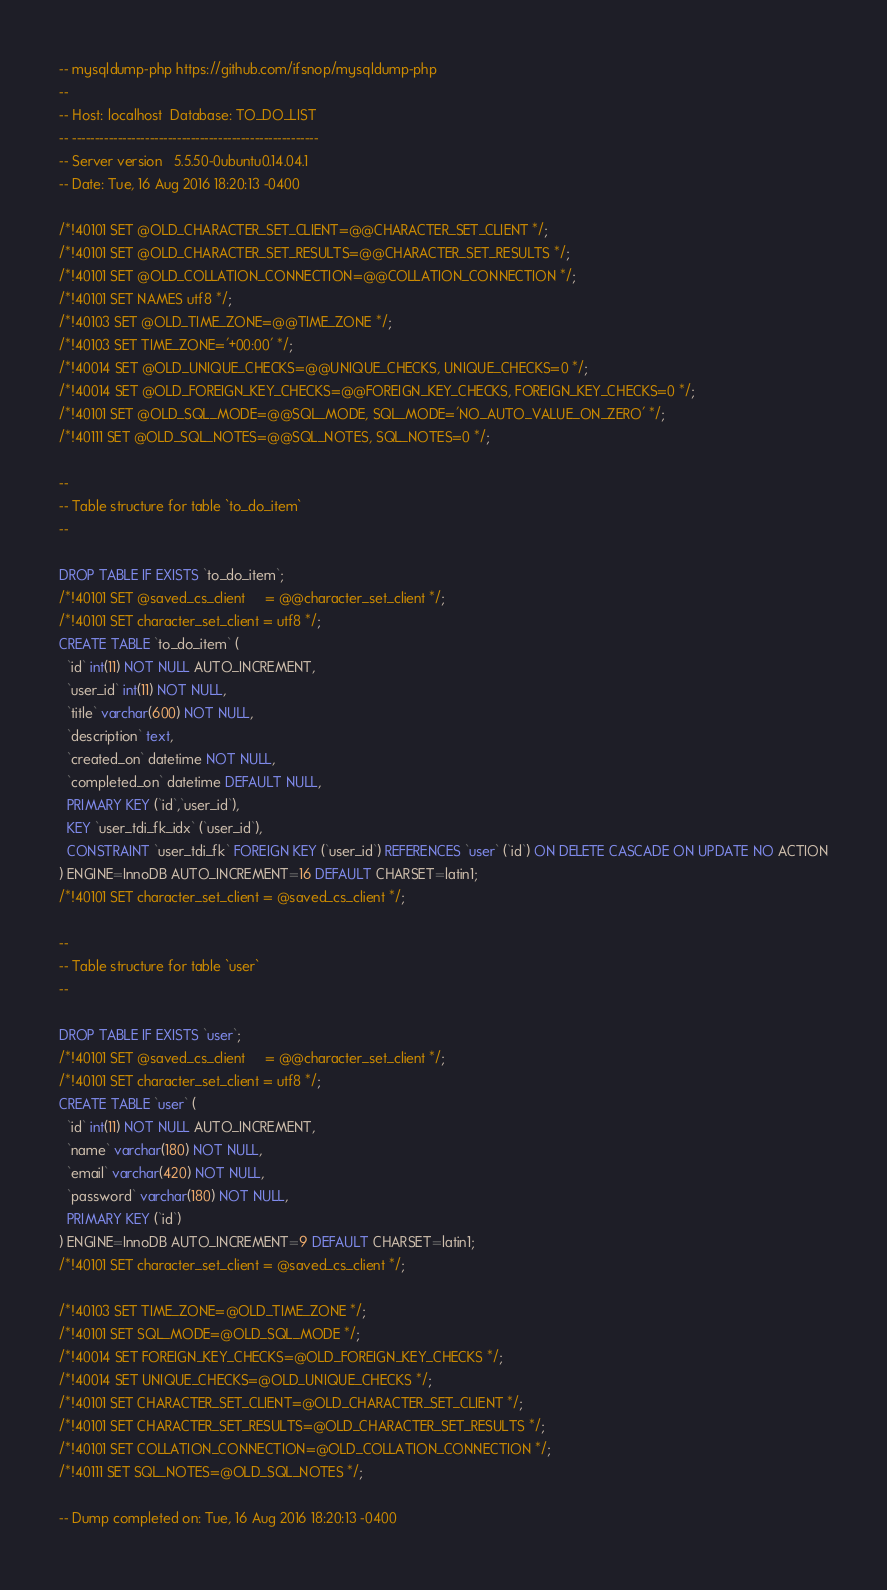Convert code to text. <code><loc_0><loc_0><loc_500><loc_500><_SQL_>-- mysqldump-php https://github.com/ifsnop/mysqldump-php
--
-- Host: localhost	Database: TO_DO_LIST
-- ------------------------------------------------------
-- Server version 	5.5.50-0ubuntu0.14.04.1
-- Date: Tue, 16 Aug 2016 18:20:13 -0400

/*!40101 SET @OLD_CHARACTER_SET_CLIENT=@@CHARACTER_SET_CLIENT */;
/*!40101 SET @OLD_CHARACTER_SET_RESULTS=@@CHARACTER_SET_RESULTS */;
/*!40101 SET @OLD_COLLATION_CONNECTION=@@COLLATION_CONNECTION */;
/*!40101 SET NAMES utf8 */;
/*!40103 SET @OLD_TIME_ZONE=@@TIME_ZONE */;
/*!40103 SET TIME_ZONE='+00:00' */;
/*!40014 SET @OLD_UNIQUE_CHECKS=@@UNIQUE_CHECKS, UNIQUE_CHECKS=0 */;
/*!40014 SET @OLD_FOREIGN_KEY_CHECKS=@@FOREIGN_KEY_CHECKS, FOREIGN_KEY_CHECKS=0 */;
/*!40101 SET @OLD_SQL_MODE=@@SQL_MODE, SQL_MODE='NO_AUTO_VALUE_ON_ZERO' */;
/*!40111 SET @OLD_SQL_NOTES=@@SQL_NOTES, SQL_NOTES=0 */;

--
-- Table structure for table `to_do_item`
--

DROP TABLE IF EXISTS `to_do_item`;
/*!40101 SET @saved_cs_client     = @@character_set_client */;
/*!40101 SET character_set_client = utf8 */;
CREATE TABLE `to_do_item` (
  `id` int(11) NOT NULL AUTO_INCREMENT,
  `user_id` int(11) NOT NULL,
  `title` varchar(600) NOT NULL,
  `description` text,
  `created_on` datetime NOT NULL,
  `completed_on` datetime DEFAULT NULL,
  PRIMARY KEY (`id`,`user_id`),
  KEY `user_tdi_fk_idx` (`user_id`),
  CONSTRAINT `user_tdi_fk` FOREIGN KEY (`user_id`) REFERENCES `user` (`id`) ON DELETE CASCADE ON UPDATE NO ACTION
) ENGINE=InnoDB AUTO_INCREMENT=16 DEFAULT CHARSET=latin1;
/*!40101 SET character_set_client = @saved_cs_client */;

--
-- Table structure for table `user`
--

DROP TABLE IF EXISTS `user`;
/*!40101 SET @saved_cs_client     = @@character_set_client */;
/*!40101 SET character_set_client = utf8 */;
CREATE TABLE `user` (
  `id` int(11) NOT NULL AUTO_INCREMENT,
  `name` varchar(180) NOT NULL,
  `email` varchar(420) NOT NULL,
  `password` varchar(180) NOT NULL,
  PRIMARY KEY (`id`)
) ENGINE=InnoDB AUTO_INCREMENT=9 DEFAULT CHARSET=latin1;
/*!40101 SET character_set_client = @saved_cs_client */;

/*!40103 SET TIME_ZONE=@OLD_TIME_ZONE */;
/*!40101 SET SQL_MODE=@OLD_SQL_MODE */;
/*!40014 SET FOREIGN_KEY_CHECKS=@OLD_FOREIGN_KEY_CHECKS */;
/*!40014 SET UNIQUE_CHECKS=@OLD_UNIQUE_CHECKS */;
/*!40101 SET CHARACTER_SET_CLIENT=@OLD_CHARACTER_SET_CLIENT */;
/*!40101 SET CHARACTER_SET_RESULTS=@OLD_CHARACTER_SET_RESULTS */;
/*!40101 SET COLLATION_CONNECTION=@OLD_COLLATION_CONNECTION */;
/*!40111 SET SQL_NOTES=@OLD_SQL_NOTES */;

-- Dump completed on: Tue, 16 Aug 2016 18:20:13 -0400
</code> 